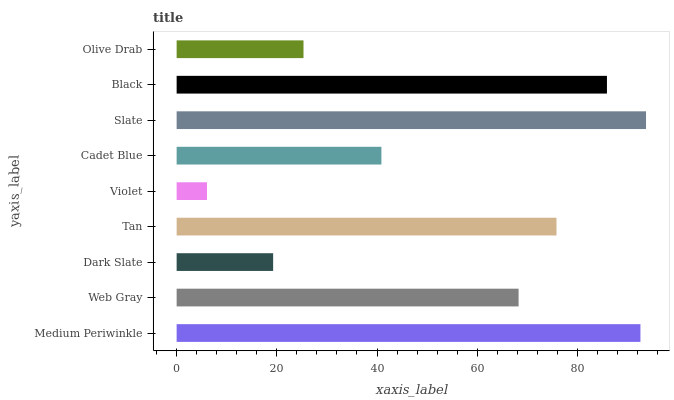Is Violet the minimum?
Answer yes or no. Yes. Is Slate the maximum?
Answer yes or no. Yes. Is Web Gray the minimum?
Answer yes or no. No. Is Web Gray the maximum?
Answer yes or no. No. Is Medium Periwinkle greater than Web Gray?
Answer yes or no. Yes. Is Web Gray less than Medium Periwinkle?
Answer yes or no. Yes. Is Web Gray greater than Medium Periwinkle?
Answer yes or no. No. Is Medium Periwinkle less than Web Gray?
Answer yes or no. No. Is Web Gray the high median?
Answer yes or no. Yes. Is Web Gray the low median?
Answer yes or no. Yes. Is Olive Drab the high median?
Answer yes or no. No. Is Black the low median?
Answer yes or no. No. 